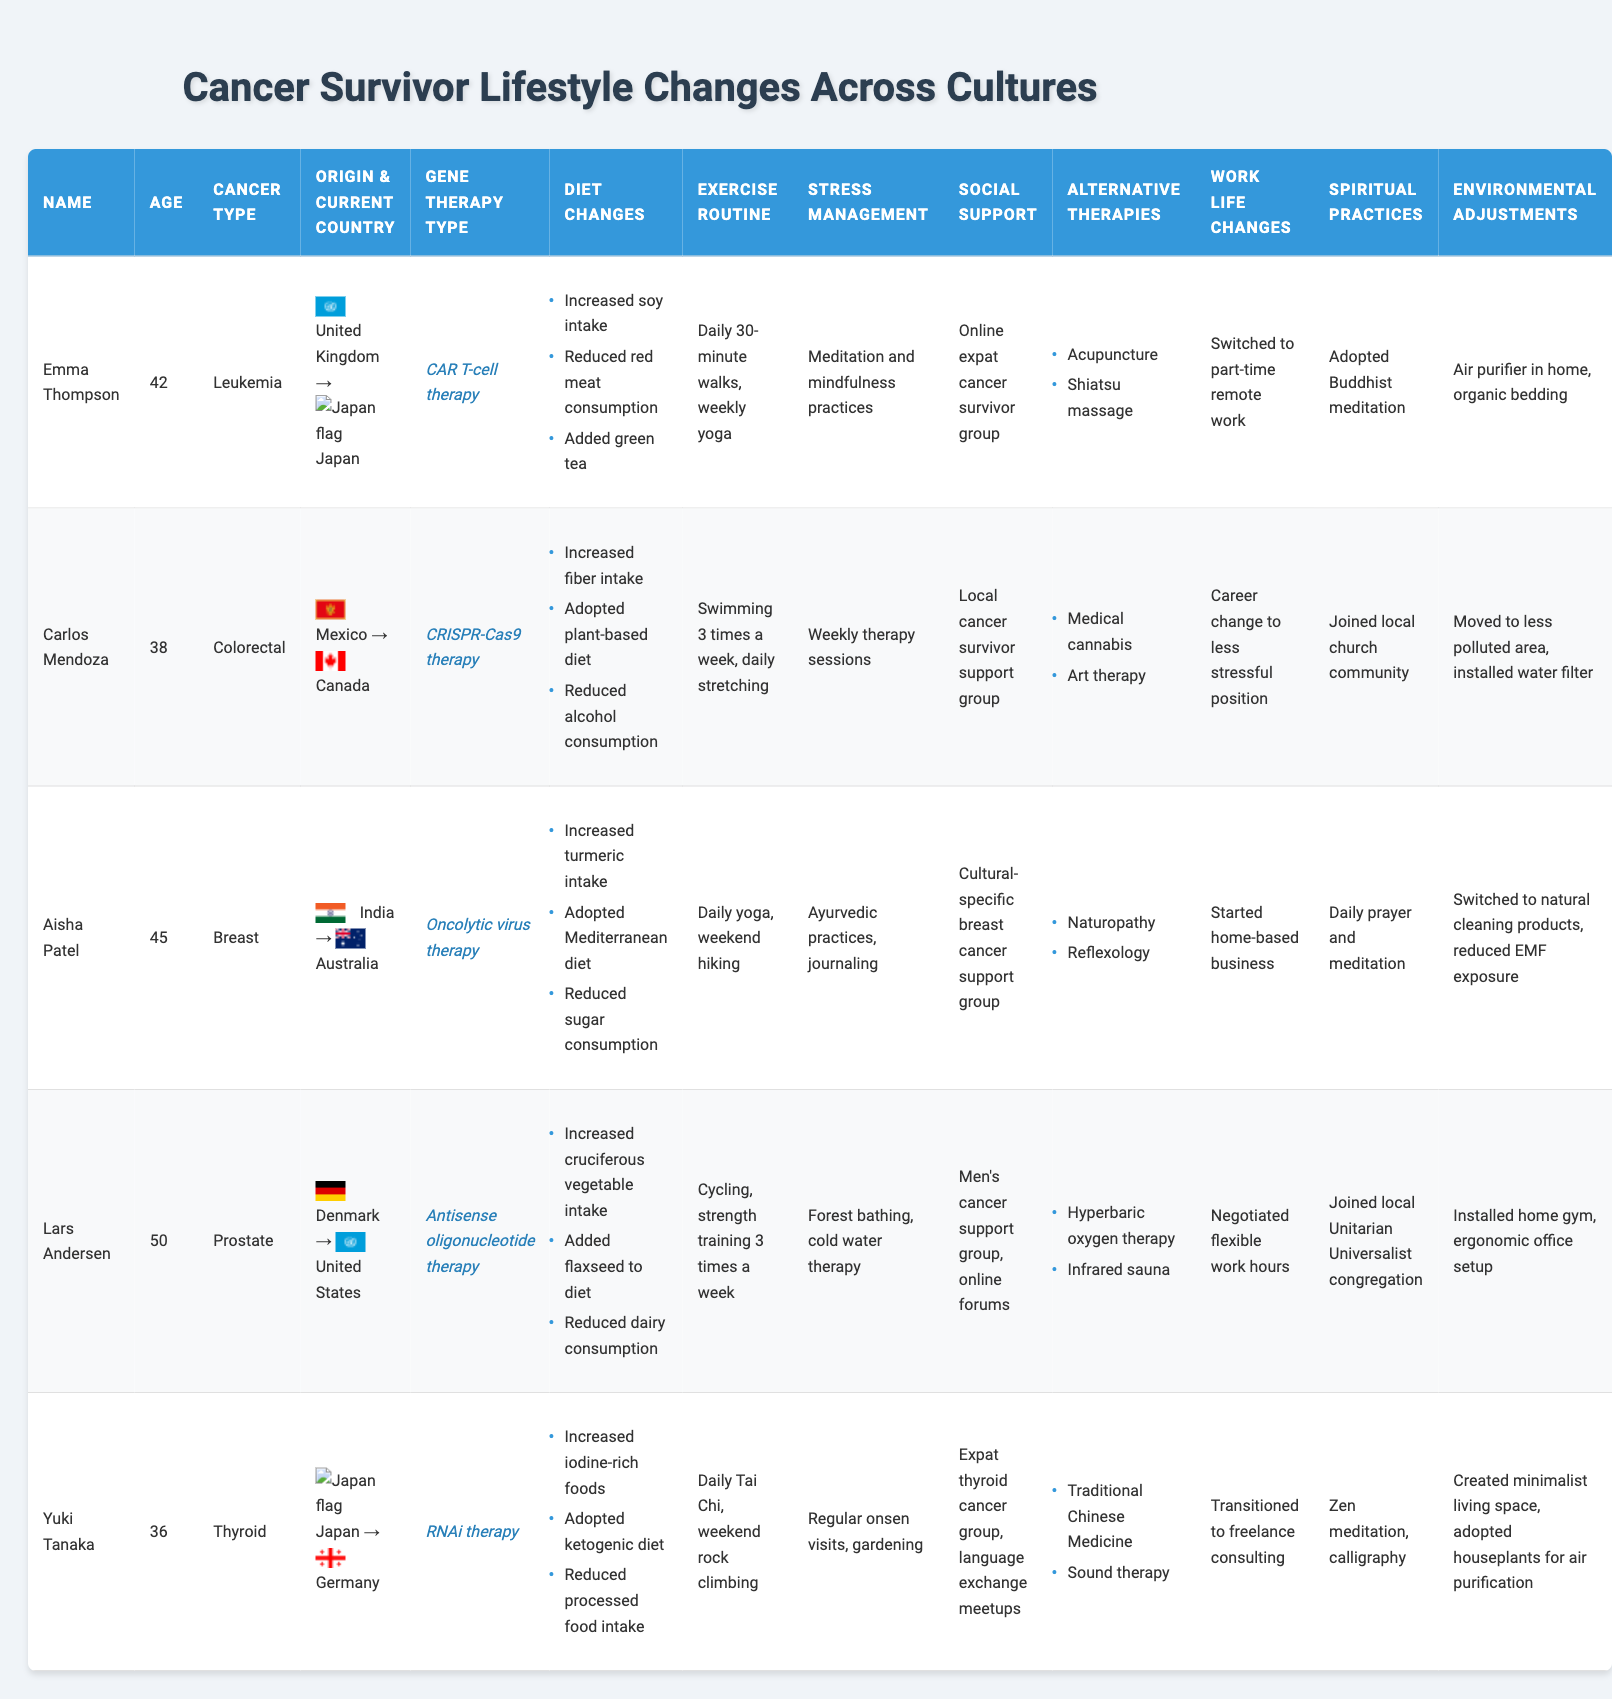What type of cancer did Emma Thompson have? By inspecting the table, I can see that under the "Cancer Type" column for Emma Thompson, it lists "Leukemia." Therefore, her cancer type is leukemia.
Answer: Leukemia How many survivors are from countries in Asia? By reviewing the "Country of Origin" column, we see that Emma Thompson (UK), Carlos Mendoza (Mexico), Aisha Patel (India), Lars Andersen (Denmark), and Yuki Tanaka (Japan) are included. Aisha Patel and Yuki Tanaka are from countries in Asia (India and Japan). Counting them gives 2 survivors.
Answer: 2 What was Carlos Mendoza's exercise routine? Looking at the "Exercise Routine" column for Carlos Mendoza, it specifies that he swims three times a week and does daily stretching. Hence, this is his exercise routine.
Answer: Swimming 3 times a week, daily stretching Which survivor adopted a plant-based diet? From the "Diet Changes" section for each survivor, I can find that Carlos Mendoza lists "Adopted plant-based diet" as one of his dietary changes. Therefore, he is the survivor who adopted this diet.
Answer: Carlos Mendoza What percentage of survivors reported alternative therapies? From the table, all five survivors mentioned at least one form of alternative therapy, confirming that 100% of the survivors reported them. Therefore, it is 100%.
Answer: 100% Who practiced Zen meditation as a spiritual practice? By checking the "Spiritual Practices" column, it shows that Yuki Tanaka adopted Zen meditation. Thus, she is the person practicing this.
Answer: Yuki Tanaka What is the average age of the survivors listed in the table? The ages of the survivors are 42, 38, 45, 50, and 36. Summing these gives 211 (42 + 38 + 45 + 50 + 36). To find the average, I divide by the number of survivors (5), resulting in 211/5 = 42.2.
Answer: 42.2 Did any survivors change their work life to less stressful positions? By examining the "Work Life Changes" column, I find that Carlos Mendoza indicates he made a career change to a less stressful position. Thus, the answer is yes.
Answer: Yes Which dietary changes are common among the survivors? I will verify the diet changes for each survivor listed in the table. Notably, while some specifics differ, a pattern emerges where increased vegetable and reduced processed food intake appear multiple times. However, no single dietary change is consistent among all, reflecting varied adaptations.
Answer: No common dietary changes Which survivor moved to less polluted areas after their diagnosis? Investigating the "Environmental Adjustments" section reveals that Carlos Mendoza stated he moved to a less polluted area. Consequently, he is the survivor that made this move.
Answer: Carlos Mendoza 